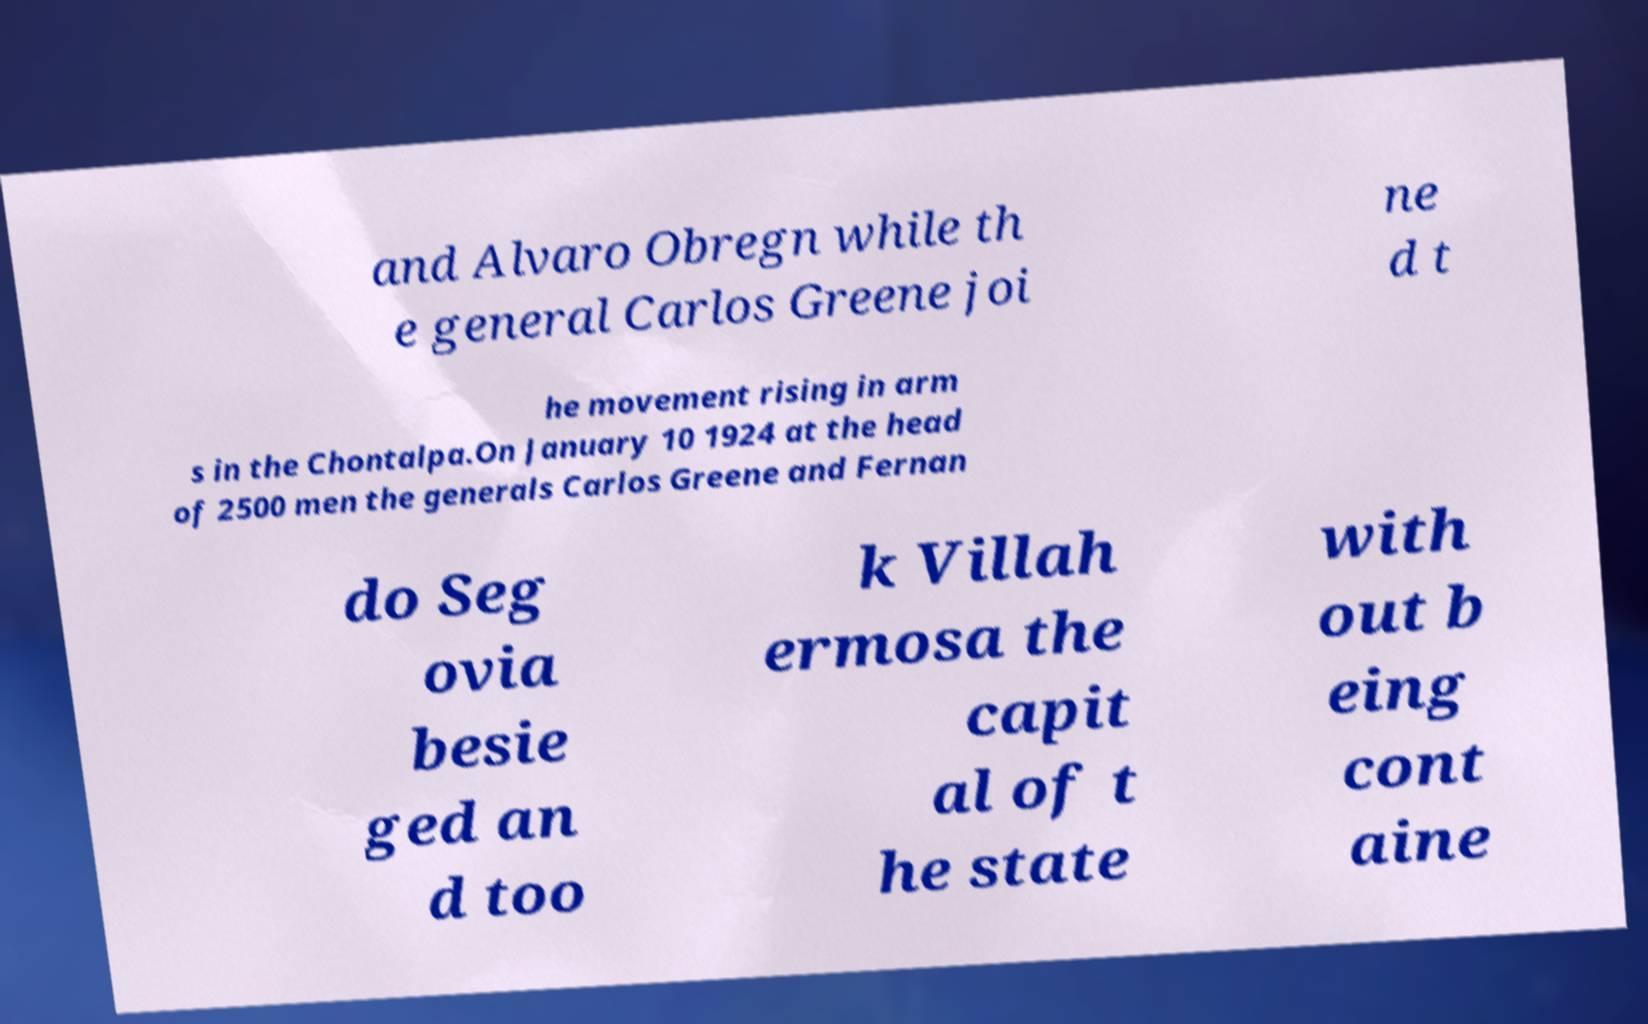What messages or text are displayed in this image? I need them in a readable, typed format. and Alvaro Obregn while th e general Carlos Greene joi ne d t he movement rising in arm s in the Chontalpa.On January 10 1924 at the head of 2500 men the generals Carlos Greene and Fernan do Seg ovia besie ged an d too k Villah ermosa the capit al of t he state with out b eing cont aine 